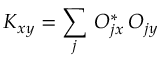Convert formula to latex. <formula><loc_0><loc_0><loc_500><loc_500>K _ { x y } = \sum _ { j } \, O _ { j x } ^ { * } \, O _ { j y }</formula> 